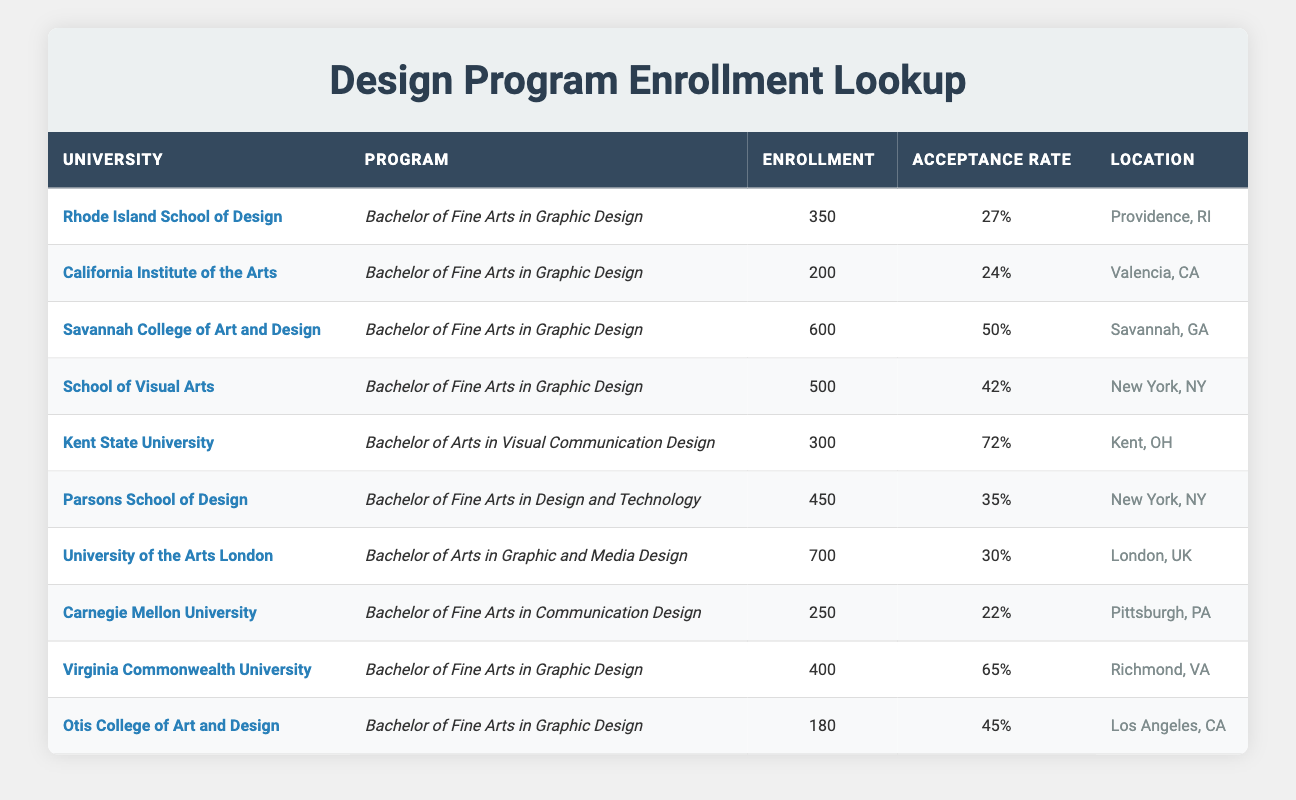What university has the highest enrollment for a design program? Looking at the enrollment numbers in the table, the university with the highest enrollment is the University of the Arts London, which has an enrollment of 700 students.
Answer: University of the Arts London Which program at Kent State University has the highest acceptance rate? From the data, Kent State University offers a Bachelor of Arts in Visual Communication Design, and its acceptance rate is 72%, which is the highest among all programs at that university.
Answer: Bachelor of Arts in Visual Communication Design How many more students are enrolled at Savannah College of Art and Design than at California Institute of the Arts? Savannah College of Art and Design has an enrollment of 600 students, while California Institute of the Arts has 200 students. The difference is calculated as 600 - 200 = 400.
Answer: 400 Is the acceptance rate for programs at the School of Visual Arts higher than 40%? The acceptance rate for the Bachelor of Fine Arts in Graphic Design at the School of Visual Arts is 42%, which is indeed higher than 40%.
Answer: Yes What is the average enrollment of all design programs listed in the table? To find the average enrollment, first sum the enrollments: 350 + 200 + 600 + 500 + 300 + 450 + 700 + 250 + 400 + 180 = 3130. There are 10 programs, so the average is 3130/10 = 313.
Answer: 313 Which university has the lowest acceptance rate, and what is that rate? By inspecting the table, Carnegie Mellon University has the lowest acceptance rate of 22%.
Answer: Carnegie Mellon University, 22% Are there more design programs offered in New York, NY, or in Los Angeles, CA? There are three design programs listed for New York, NY (School of Visual Arts, Parsons School of Design) and one for Los Angeles, CA (Otis College of Art and Design). Therefore, New York offers more programs.
Answer: New York, NY What is the total enrollment of all design programs from universities located in California? The universities in California are California Institute of the Arts and Otis College of Art and Design, with enrollments of 200 and 180, respectively. Adding these gives 200 + 180 = 380.
Answer: 380 What percentage of students are accepted into the Bachelor of Fine Arts program at Virginia Commonwealth University? The acceptance rate for the Bachelor of Fine Arts in Graphic Design at Virginia Commonwealth University is given as 65%, indicating that 65% of applicants are accepted.
Answer: 65% 